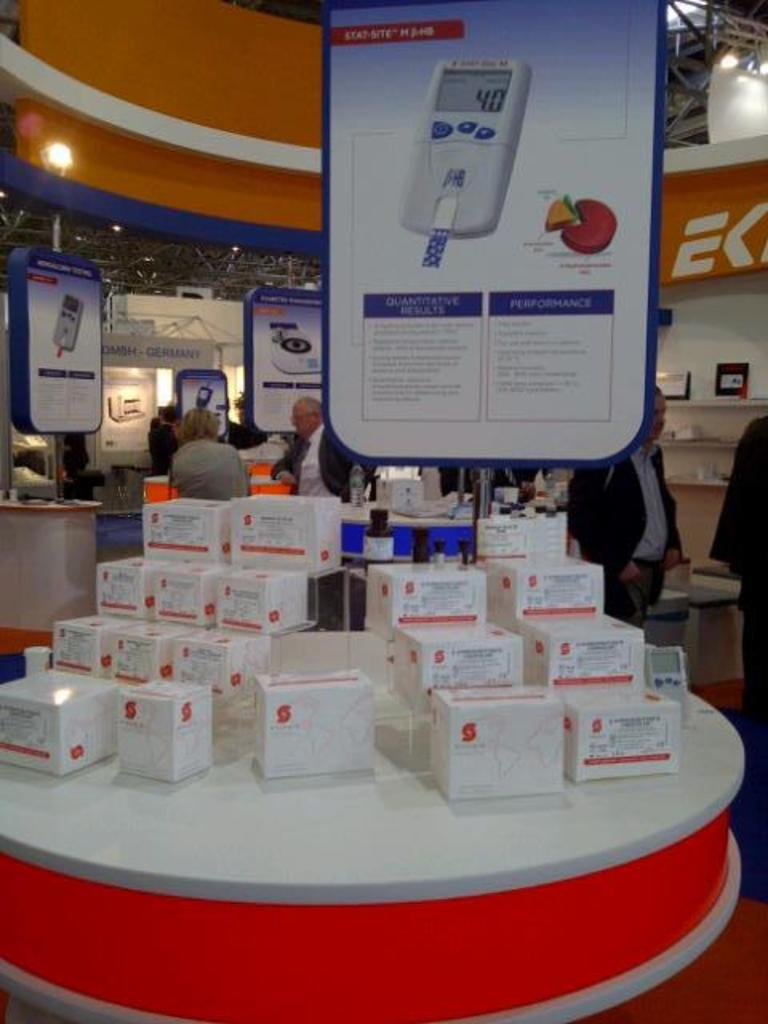<image>
Offer a succinct explanation of the picture presented. At a technology conference, a display of a health device is on a table. 